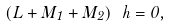Convert formula to latex. <formula><loc_0><loc_0><loc_500><loc_500>\left ( L + M _ { 1 } + M _ { 2 } \right ) \ h = 0 ,</formula> 